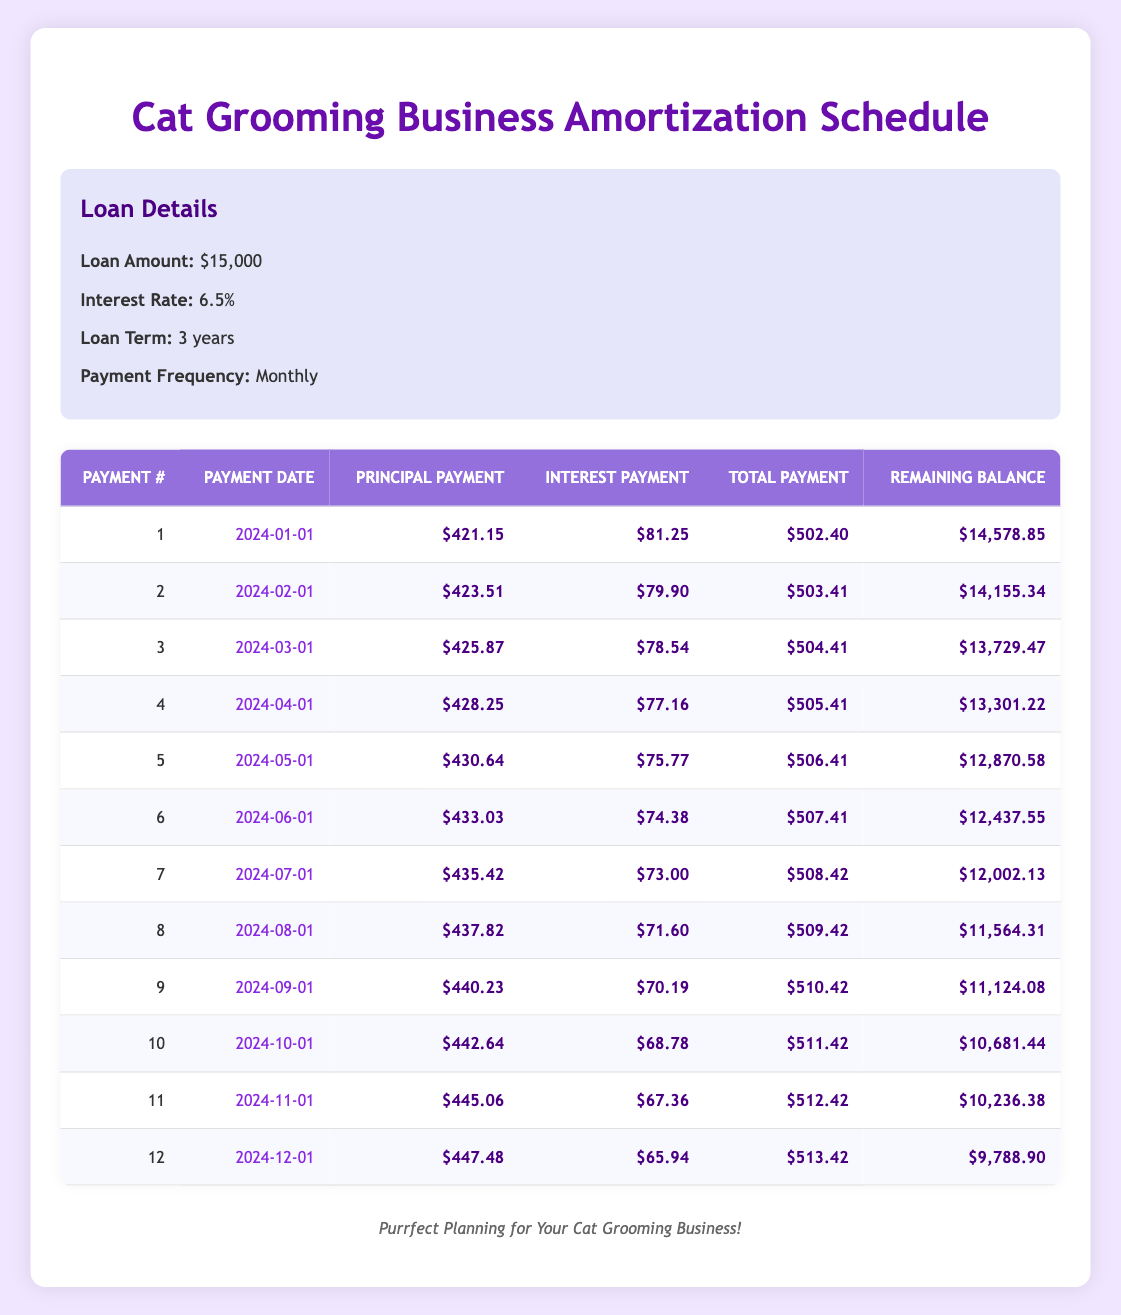What is the total payment for the first month? The table shows that the total payment for the first month (Payment #1) is listed in the "Total Payment" column under payment number 1, which is $502.40.
Answer: 502.40 What is the principal payment in the sixth month? The principal payment for the sixth month (Payment #6) can be found in the "Principal Payment" column corresponding to payment number 6, which is $433.03.
Answer: 433.03 What is the remaining balance after the third payment? To find the remaining balance after the third payment (Payment #3), we look under the "Remaining Balance" column for payment number 3, which is $13,729.47.
Answer: 13,729.47 What is the total amount paid in the first year? To calculate the total paid in the first year, we sum the total payments for the first 12 payments: $502.40 + $503.41 + $504.41 + $505.41 + $506.41 + $507.41 + $508.42 + $509.42 + $510.42 + $511.42 + $512.42 + $513.42. This totals to $6,077.63.
Answer: 6,077.63 Is the interest payment in the second month lower than the first month? By reviewing the "Interest Payment" column, the interest payment in the second month (Payment #2) is $79.90, while in the first month (Payment #1) it is $81.25. Since $79.90 is less than $81.25, the statement is true.
Answer: Yes What is the average principal payment over the first 12 months? To find the average principal payment, we sum up the principal payments for all 12 months: $421.15 + $423.51 + $425.87 + $428.25 + $430.64 + $433.03 + $435.42 + $437.82 + $440.23 + $442.64 + $445.06 + $447.48 = $5,219.10. Dividing this by 12 gives us an average of $434.93.
Answer: 434.93 What is the difference in total payment between the fifth and the tenth month? The total payments for the fifth month (Payment #5) is $506.41 and for the tenth month (Payment #10) is $511.42. The difference can be calculated by $511.42 - $506.41 = $5.01.
Answer: 5.01 What is the total interest paid in the first year? The total interest paid in the first year can be calculated by summing the interest payments for all 12 months: $81.25 + $79.90 + $78.54 + $77.16 + $75.77 + $74.38 + $73.00 + $71.60 + $70.19 + $68.78 + $67.36 + $65.94. This totals to $1,039.80.
Answer: 1,039.80 